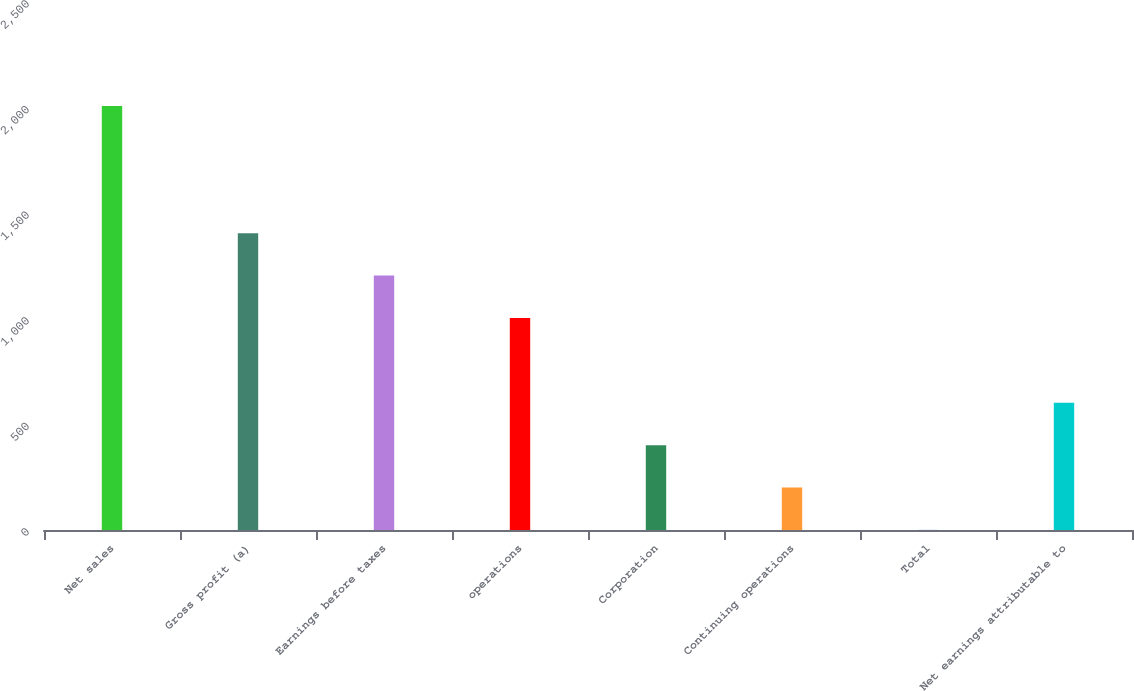Convert chart to OTSL. <chart><loc_0><loc_0><loc_500><loc_500><bar_chart><fcel>Net sales<fcel>Gross profit (a)<fcel>Earnings before taxes<fcel>operations<fcel>Corporation<fcel>Continuing operations<fcel>Total<fcel>Net earnings attributable to<nl><fcel>2007.5<fcel>1405.34<fcel>1204.63<fcel>1003.92<fcel>401.79<fcel>201.08<fcel>0.37<fcel>602.5<nl></chart> 